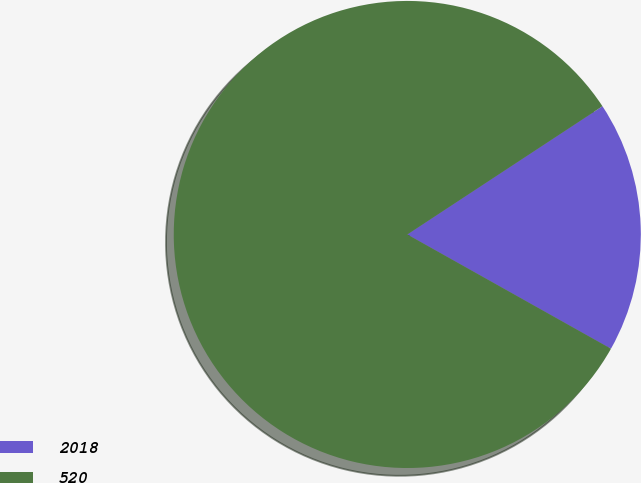Convert chart to OTSL. <chart><loc_0><loc_0><loc_500><loc_500><pie_chart><fcel>2018<fcel>520<nl><fcel>17.39%<fcel>82.61%<nl></chart> 